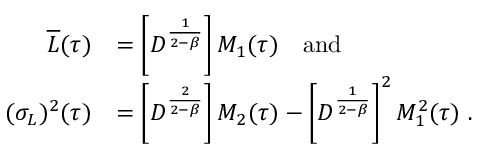<formula> <loc_0><loc_0><loc_500><loc_500>\begin{array} { r l } { \overline { L } ( \tau ) } & { = \left [ D ^ { \frac { 1 } { 2 - \beta } } \right ] M _ { 1 } ( \tau ) \quad a n d } \\ { ( \sigma _ { L } ) ^ { 2 } ( \tau ) } & { = \left [ D ^ { \frac { 2 } { 2 - \beta } } \right ] M _ { 2 } ( \tau ) - \left [ D ^ { \frac { 1 } { 2 - \beta } } \right ] ^ { 2 } M _ { 1 } ^ { 2 } ( \tau ) \ . } \end{array}</formula> 